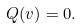Convert formula to latex. <formula><loc_0><loc_0><loc_500><loc_500>Q ( v ) = 0 .</formula> 